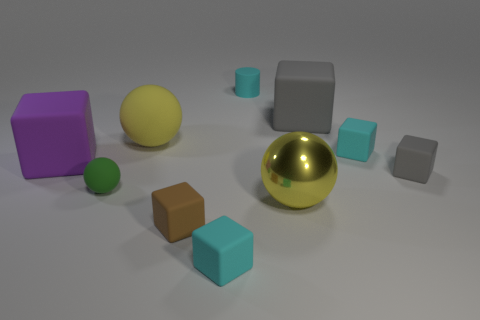What is the relative size of the purple object compared to the other shapes? The purple object, which is a cube, is the largest shape in the image. It stands out not only due to its color but also due to its size, as it is bulkier and appears to have more volume than the other geometrical figures present. 